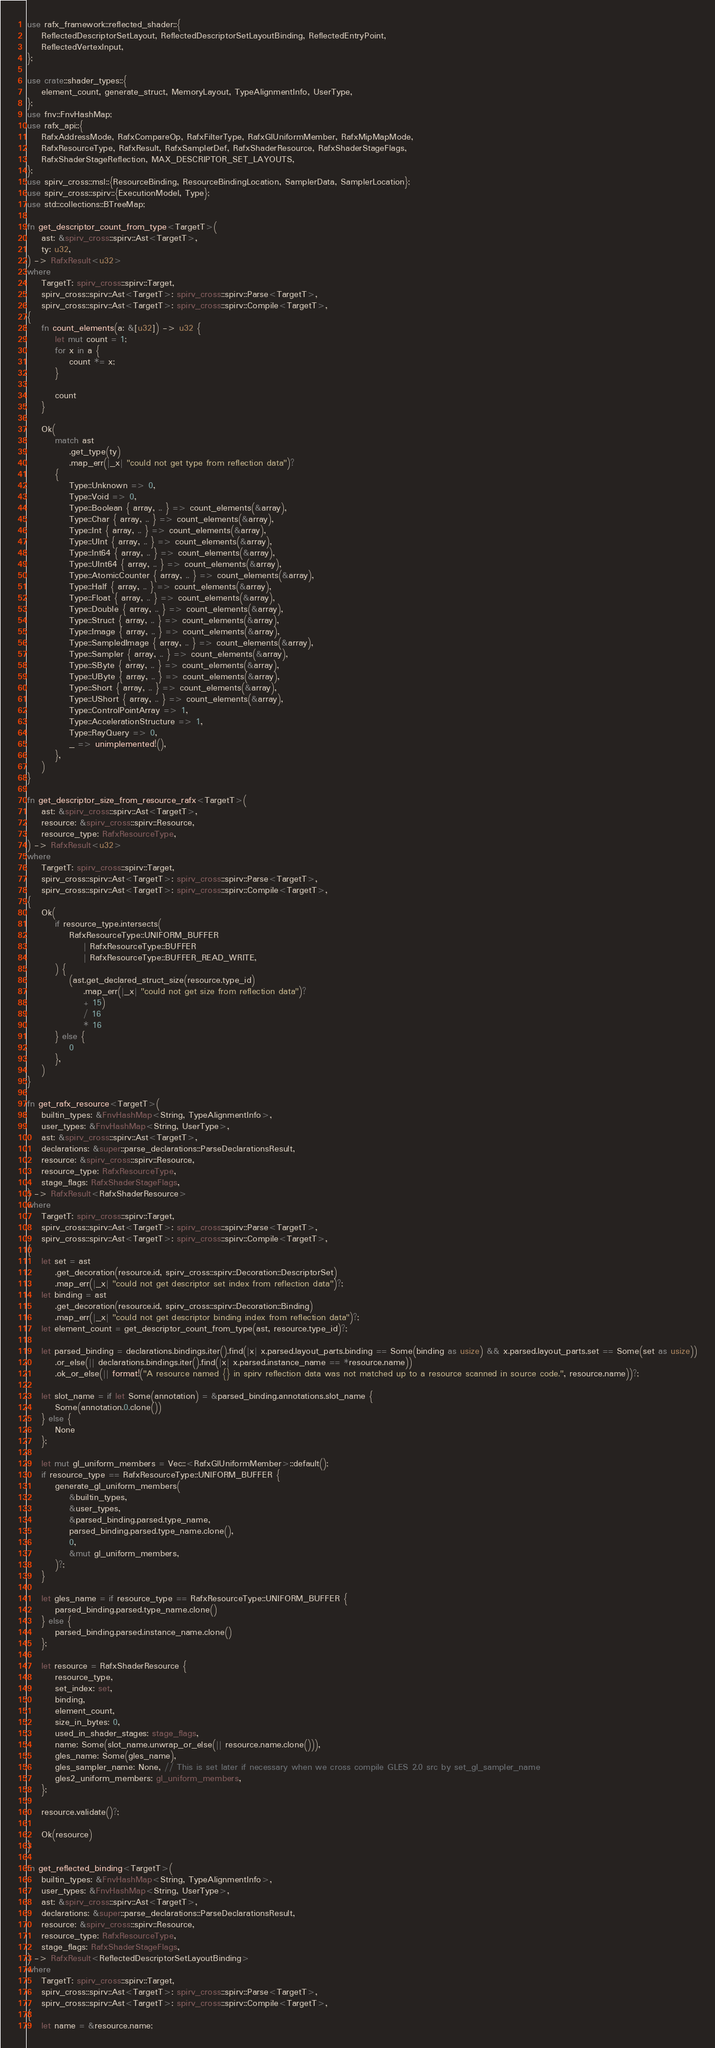Convert code to text. <code><loc_0><loc_0><loc_500><loc_500><_Rust_>use rafx_framework::reflected_shader::{
    ReflectedDescriptorSetLayout, ReflectedDescriptorSetLayoutBinding, ReflectedEntryPoint,
    ReflectedVertexInput,
};

use crate::shader_types::{
    element_count, generate_struct, MemoryLayout, TypeAlignmentInfo, UserType,
};
use fnv::FnvHashMap;
use rafx_api::{
    RafxAddressMode, RafxCompareOp, RafxFilterType, RafxGlUniformMember, RafxMipMapMode,
    RafxResourceType, RafxResult, RafxSamplerDef, RafxShaderResource, RafxShaderStageFlags,
    RafxShaderStageReflection, MAX_DESCRIPTOR_SET_LAYOUTS,
};
use spirv_cross::msl::{ResourceBinding, ResourceBindingLocation, SamplerData, SamplerLocation};
use spirv_cross::spirv::{ExecutionModel, Type};
use std::collections::BTreeMap;

fn get_descriptor_count_from_type<TargetT>(
    ast: &spirv_cross::spirv::Ast<TargetT>,
    ty: u32,
) -> RafxResult<u32>
where
    TargetT: spirv_cross::spirv::Target,
    spirv_cross::spirv::Ast<TargetT>: spirv_cross::spirv::Parse<TargetT>,
    spirv_cross::spirv::Ast<TargetT>: spirv_cross::spirv::Compile<TargetT>,
{
    fn count_elements(a: &[u32]) -> u32 {
        let mut count = 1;
        for x in a {
            count *= x;
        }

        count
    }

    Ok(
        match ast
            .get_type(ty)
            .map_err(|_x| "could not get type from reflection data")?
        {
            Type::Unknown => 0,
            Type::Void => 0,
            Type::Boolean { array, .. } => count_elements(&array),
            Type::Char { array, .. } => count_elements(&array),
            Type::Int { array, .. } => count_elements(&array),
            Type::UInt { array, .. } => count_elements(&array),
            Type::Int64 { array, .. } => count_elements(&array),
            Type::UInt64 { array, .. } => count_elements(&array),
            Type::AtomicCounter { array, .. } => count_elements(&array),
            Type::Half { array, .. } => count_elements(&array),
            Type::Float { array, .. } => count_elements(&array),
            Type::Double { array, .. } => count_elements(&array),
            Type::Struct { array, .. } => count_elements(&array),
            Type::Image { array, .. } => count_elements(&array),
            Type::SampledImage { array, .. } => count_elements(&array),
            Type::Sampler { array, .. } => count_elements(&array),
            Type::SByte { array, .. } => count_elements(&array),
            Type::UByte { array, .. } => count_elements(&array),
            Type::Short { array, .. } => count_elements(&array),
            Type::UShort { array, .. } => count_elements(&array),
            Type::ControlPointArray => 1,
            Type::AccelerationStructure => 1,
            Type::RayQuery => 0,
            _ => unimplemented!(),
        },
    )
}

fn get_descriptor_size_from_resource_rafx<TargetT>(
    ast: &spirv_cross::spirv::Ast<TargetT>,
    resource: &spirv_cross::spirv::Resource,
    resource_type: RafxResourceType,
) -> RafxResult<u32>
where
    TargetT: spirv_cross::spirv::Target,
    spirv_cross::spirv::Ast<TargetT>: spirv_cross::spirv::Parse<TargetT>,
    spirv_cross::spirv::Ast<TargetT>: spirv_cross::spirv::Compile<TargetT>,
{
    Ok(
        if resource_type.intersects(
            RafxResourceType::UNIFORM_BUFFER
                | RafxResourceType::BUFFER
                | RafxResourceType::BUFFER_READ_WRITE,
        ) {
            (ast.get_declared_struct_size(resource.type_id)
                .map_err(|_x| "could not get size from reflection data")?
                + 15)
                / 16
                * 16
        } else {
            0
        },
    )
}

fn get_rafx_resource<TargetT>(
    builtin_types: &FnvHashMap<String, TypeAlignmentInfo>,
    user_types: &FnvHashMap<String, UserType>,
    ast: &spirv_cross::spirv::Ast<TargetT>,
    declarations: &super::parse_declarations::ParseDeclarationsResult,
    resource: &spirv_cross::spirv::Resource,
    resource_type: RafxResourceType,
    stage_flags: RafxShaderStageFlags,
) -> RafxResult<RafxShaderResource>
where
    TargetT: spirv_cross::spirv::Target,
    spirv_cross::spirv::Ast<TargetT>: spirv_cross::spirv::Parse<TargetT>,
    spirv_cross::spirv::Ast<TargetT>: spirv_cross::spirv::Compile<TargetT>,
{
    let set = ast
        .get_decoration(resource.id, spirv_cross::spirv::Decoration::DescriptorSet)
        .map_err(|_x| "could not get descriptor set index from reflection data")?;
    let binding = ast
        .get_decoration(resource.id, spirv_cross::spirv::Decoration::Binding)
        .map_err(|_x| "could not get descriptor binding index from reflection data")?;
    let element_count = get_descriptor_count_from_type(ast, resource.type_id)?;

    let parsed_binding = declarations.bindings.iter().find(|x| x.parsed.layout_parts.binding == Some(binding as usize) && x.parsed.layout_parts.set == Some(set as usize))
        .or_else(|| declarations.bindings.iter().find(|x| x.parsed.instance_name == *resource.name))
        .ok_or_else(|| format!("A resource named {} in spirv reflection data was not matched up to a resource scanned in source code.", resource.name))?;

    let slot_name = if let Some(annotation) = &parsed_binding.annotations.slot_name {
        Some(annotation.0.clone())
    } else {
        None
    };

    let mut gl_uniform_members = Vec::<RafxGlUniformMember>::default();
    if resource_type == RafxResourceType::UNIFORM_BUFFER {
        generate_gl_uniform_members(
            &builtin_types,
            &user_types,
            &parsed_binding.parsed.type_name,
            parsed_binding.parsed.type_name.clone(),
            0,
            &mut gl_uniform_members,
        )?;
    }

    let gles_name = if resource_type == RafxResourceType::UNIFORM_BUFFER {
        parsed_binding.parsed.type_name.clone()
    } else {
        parsed_binding.parsed.instance_name.clone()
    };

    let resource = RafxShaderResource {
        resource_type,
        set_index: set,
        binding,
        element_count,
        size_in_bytes: 0,
        used_in_shader_stages: stage_flags,
        name: Some(slot_name.unwrap_or_else(|| resource.name.clone())),
        gles_name: Some(gles_name),
        gles_sampler_name: None, // This is set later if necessary when we cross compile GLES 2.0 src by set_gl_sampler_name
        gles2_uniform_members: gl_uniform_members,
    };

    resource.validate()?;

    Ok(resource)
}

fn get_reflected_binding<TargetT>(
    builtin_types: &FnvHashMap<String, TypeAlignmentInfo>,
    user_types: &FnvHashMap<String, UserType>,
    ast: &spirv_cross::spirv::Ast<TargetT>,
    declarations: &super::parse_declarations::ParseDeclarationsResult,
    resource: &spirv_cross::spirv::Resource,
    resource_type: RafxResourceType,
    stage_flags: RafxShaderStageFlags,
) -> RafxResult<ReflectedDescriptorSetLayoutBinding>
where
    TargetT: spirv_cross::spirv::Target,
    spirv_cross::spirv::Ast<TargetT>: spirv_cross::spirv::Parse<TargetT>,
    spirv_cross::spirv::Ast<TargetT>: spirv_cross::spirv::Compile<TargetT>,
{
    let name = &resource.name;</code> 